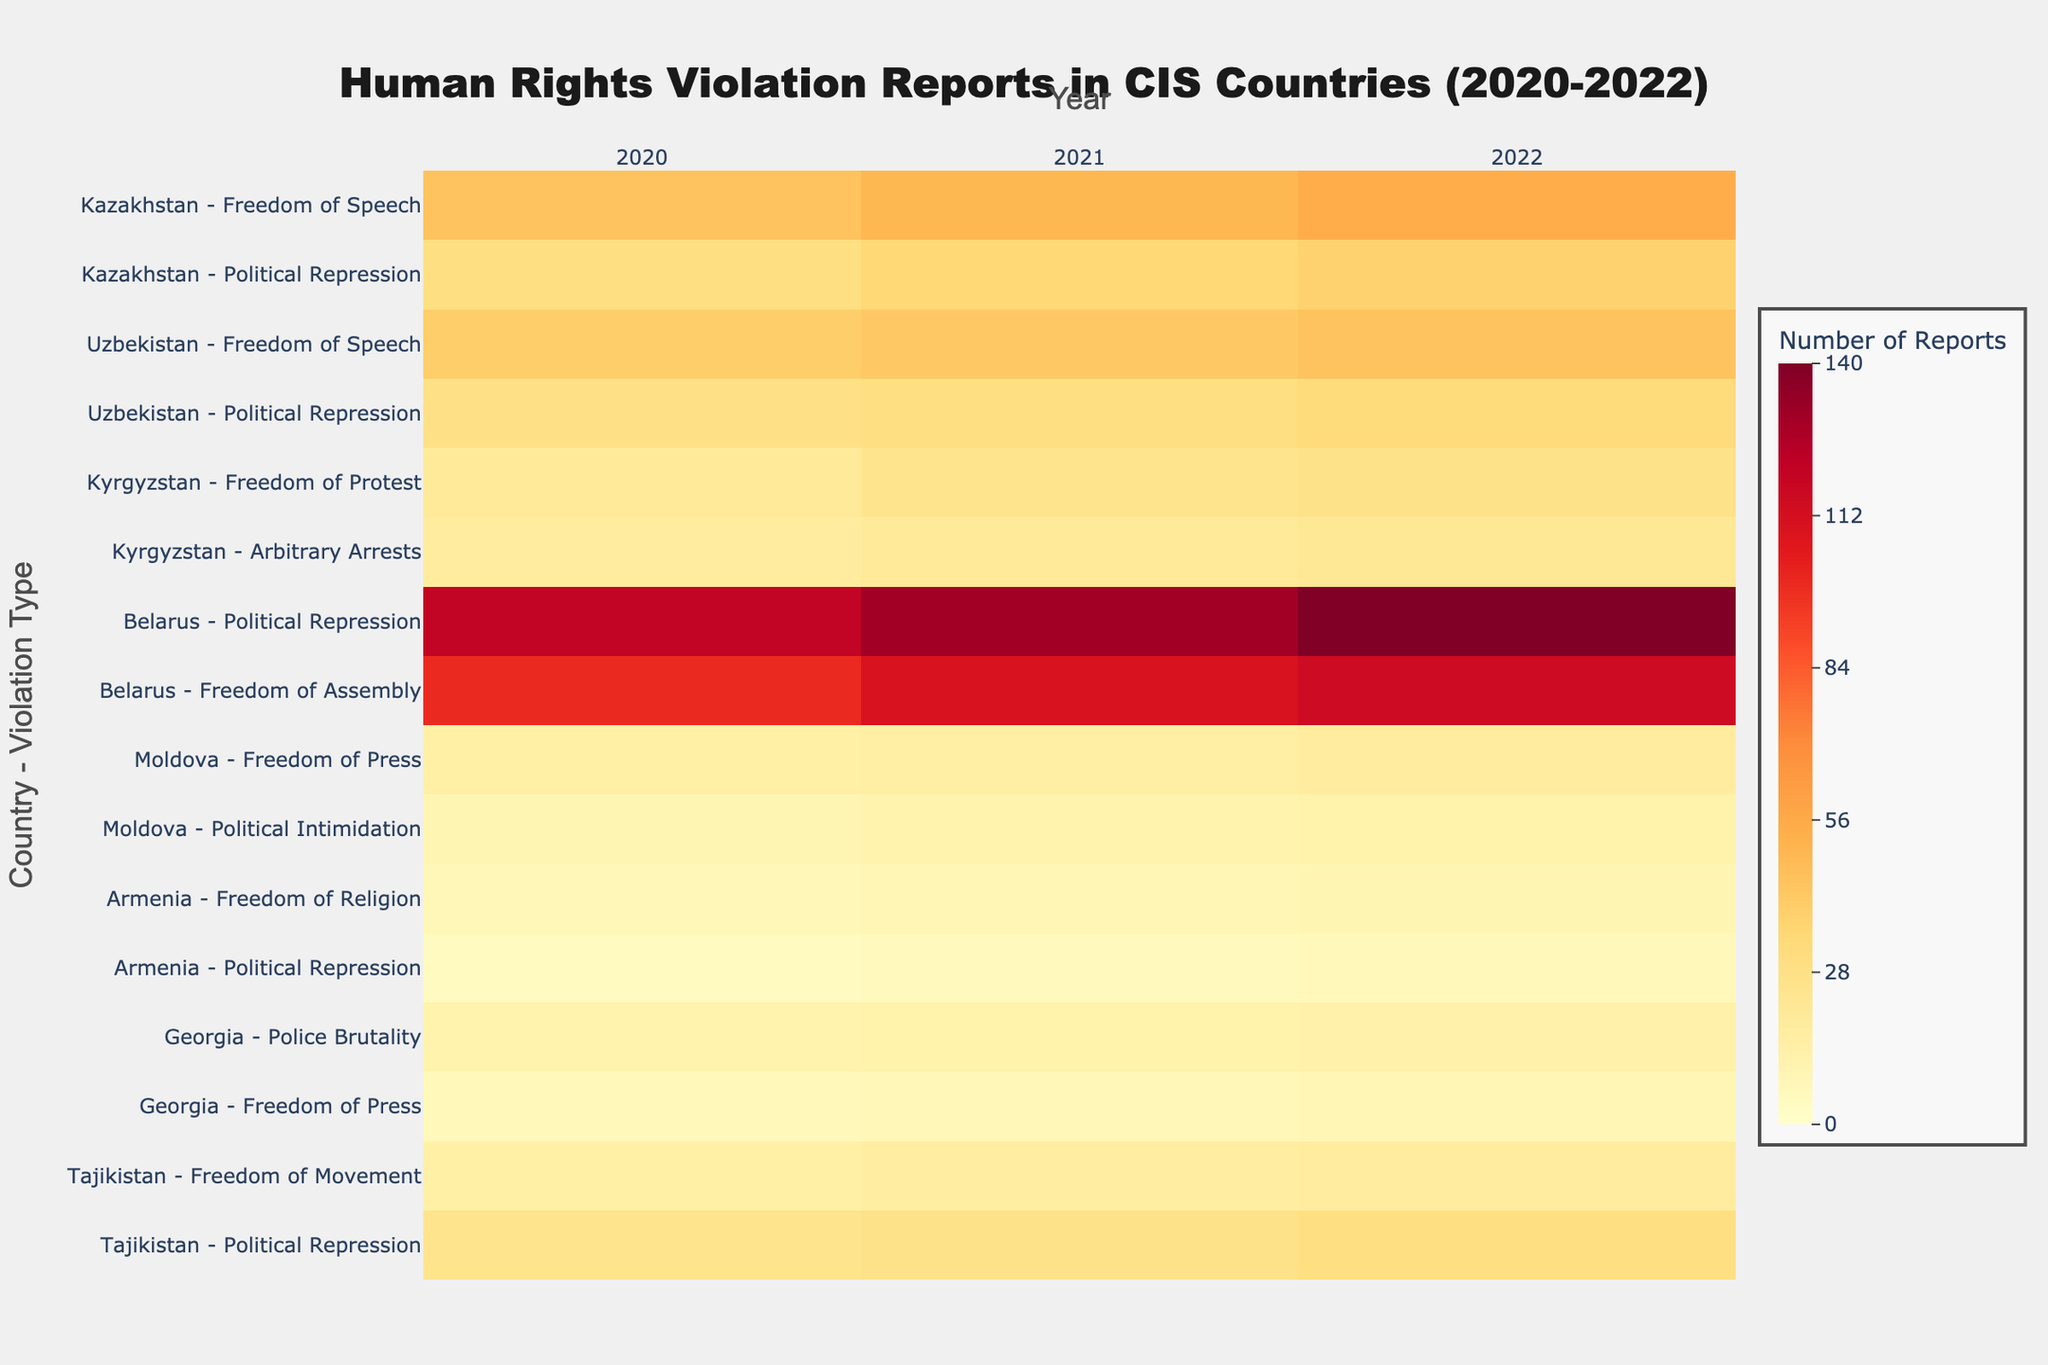Which country and violation type had the highest number of reports in 2022? Locate the 2022 column and then identify the highest value by cross-referencing with the respective country and violation type. The highest number is 140 for Belarus - Political Repression.
Answer: Belarus - Political Repression What does the color scale in the heatmap represent? The color scale ranges from light yellow to dark red, where lighter colors denote fewer reports and darker colors denote a higher number of reports.
Answer: Number of Reports How did the reports of Freedom of Speech violations change in Kazakhstan from 2020 to 2022? Look at the rows for Kazakhstan - Freedom of Speech and observe the values under each year: 45 in 2020, 50 in 2021, and 55 in 2022, indicating a steady increase.
Answer: Increased Which region had the widest range of human rights violation types reported? By examining the y-axis labels, Central Asia is found to have the most diverse set of violation types reported, spanning Freedom of Speech, Political Repression, Freedom of Protest, Arbitrary Arrests, and Freedom of Movement.
Answer: Central Asia What is the total number of reports for Political Repression in Uzbekistan over the years 2020-2022? Sum the numbers for Political Repression in Uzbekistan: 28 (2020) + 30 (2021) + 33 (2022) = 91.
Answer: 91 Compare the trends in reports of Political Repression in Belarus and Political Repression in Tajikistan. Which country showed a larger increase from 2020 to 2022? Identify values for Political Repression in both countries and calculate the differences. Belarus: 140 - 120 = 20, Tajikistan: 30 - 25 = 5. Belarus had a larger increase.
Answer: Belarus What is the average number of reports for Freedom of Press violations in Moldova over the three years? Add the reports for Freedom of Press in Moldova: 15 (2020) + 16 (2021) + 18 (2022) = 49. Divide by 3 for the average: 49 / 3 ≈ 16.33.
Answer: 16.33 Which violation type in Central Asia saw the smallest number of reports in 2022? Look at the Central Asia region and examine the 2022 values across different violation types. The smallest number is for Arbitrary Arrests in Kyrgyzstan with 22 reports.
Answer: Arbitrary Arrests in Kyrgyzstan How consistent were the reports of Freedom of Religion violations in Armenia over the three years? Check the figures for Freedom of Religion in Armenia: 8 (2020), 9 (2021), and 10 (2022). The numbers are closely spaced, indicating a consistent pattern.
Answer: Consistent What pattern do you observe for Freedom of Assembly violations in Belarus from 2020 to 2022? Check the values for Freedom of Assembly in Belarus: 100 (2020), 110 (2021), 115 (2022). The pattern shows a steady increase over the three years.
Answer: Steady increase 